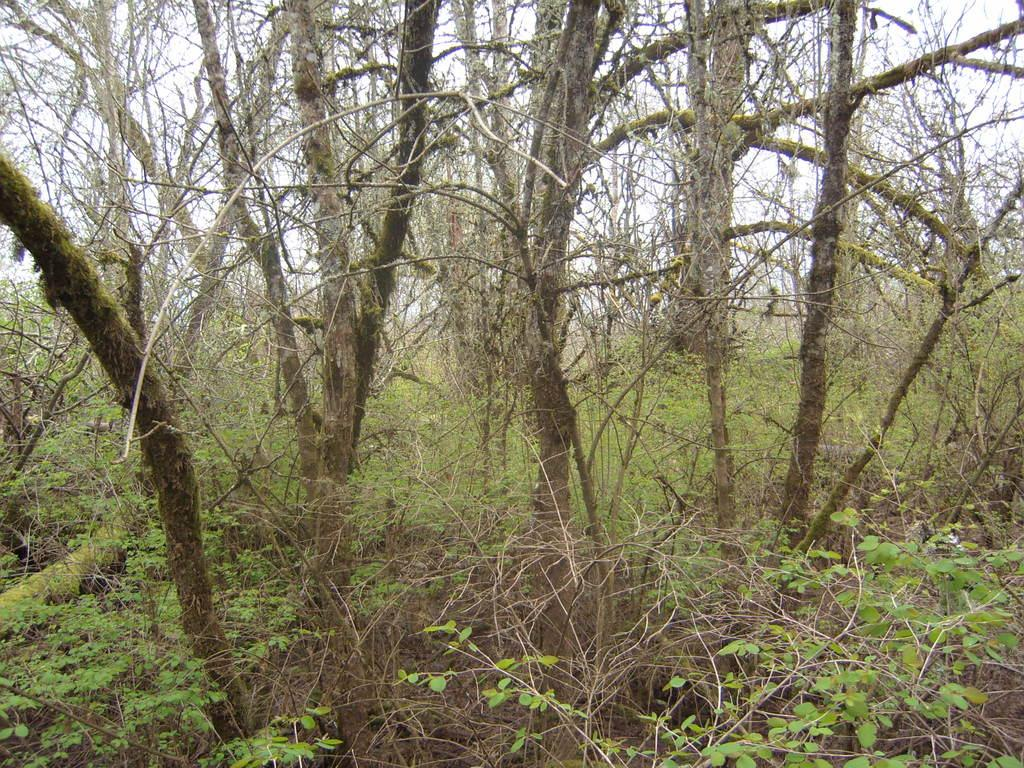What type of vegetation can be seen in the image? There is a group of trees and plants at the bottom of the image. Can you describe the trees in the image? The group of trees in the image consists of various types of trees. What is the location of the plants in the image? The plants are at the bottom of the image. What type of organization is responsible for the pleasure experienced by the turkey in the image? There is no turkey present in the image, and therefore no pleasure or organization related to it can be observed. 